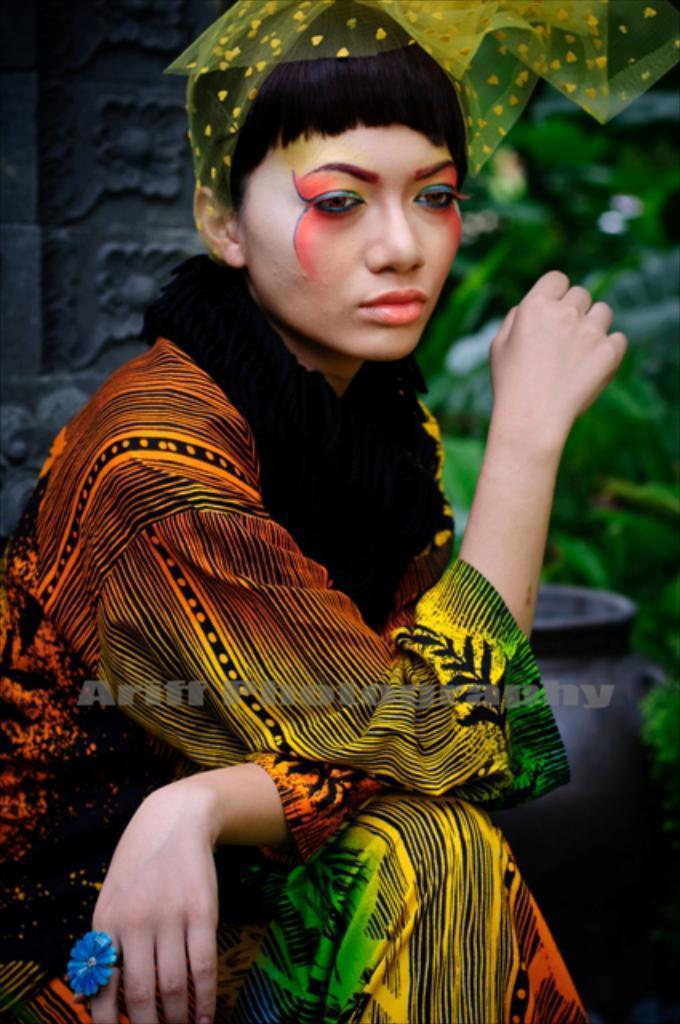Describe this image in one or two sentences. In this picture I can see a woman seated and a cloth on her head and I can see plants on the right side and a pot and a carved wall on the left side of the picture. 